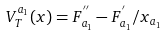<formula> <loc_0><loc_0><loc_500><loc_500>V _ { T } ^ { a _ { 1 } } ( x ) = F _ { a _ { 1 } } ^ { ^ { \prime \prime } } - F _ { a _ { 1 } } ^ { ^ { \prime } } / x _ { a _ { 1 } }</formula> 